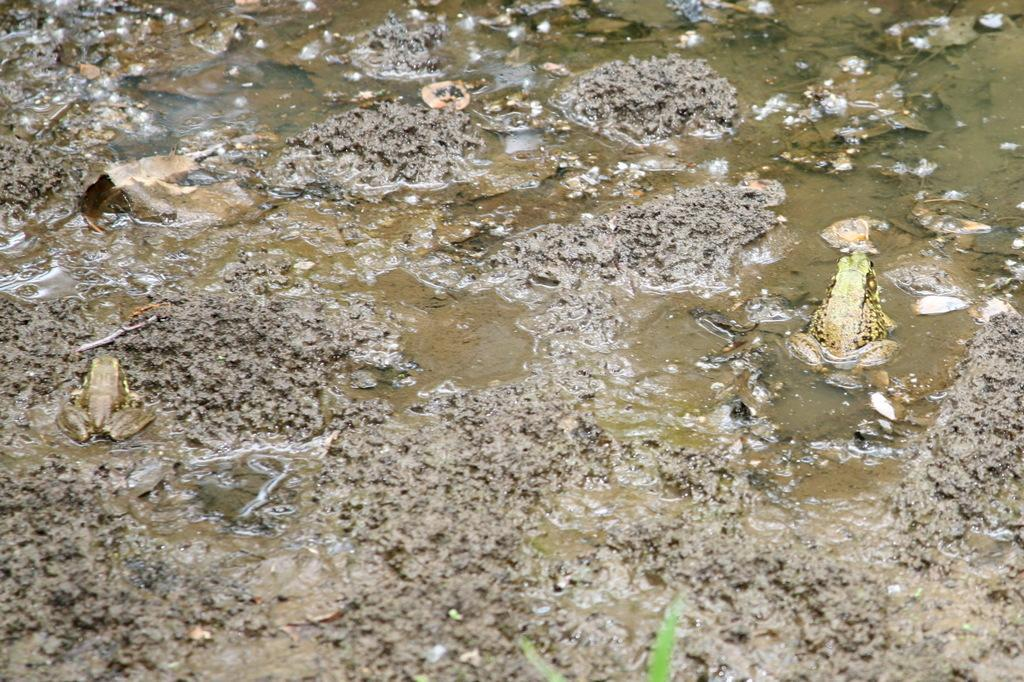What animals can be seen in the foreground of the image? There are two frogs in the foreground of the image. What surface are the frogs on? The frogs are on the mud. What type of terrain is visible in the image? There is mud and water visible in the image. What additional objects can be seen at the bottom of the image? There are two leafs on the bottom of the image. What type of dress is the frog wearing in the image? Frogs do not wear dresses, and there is no dress present in the image. 